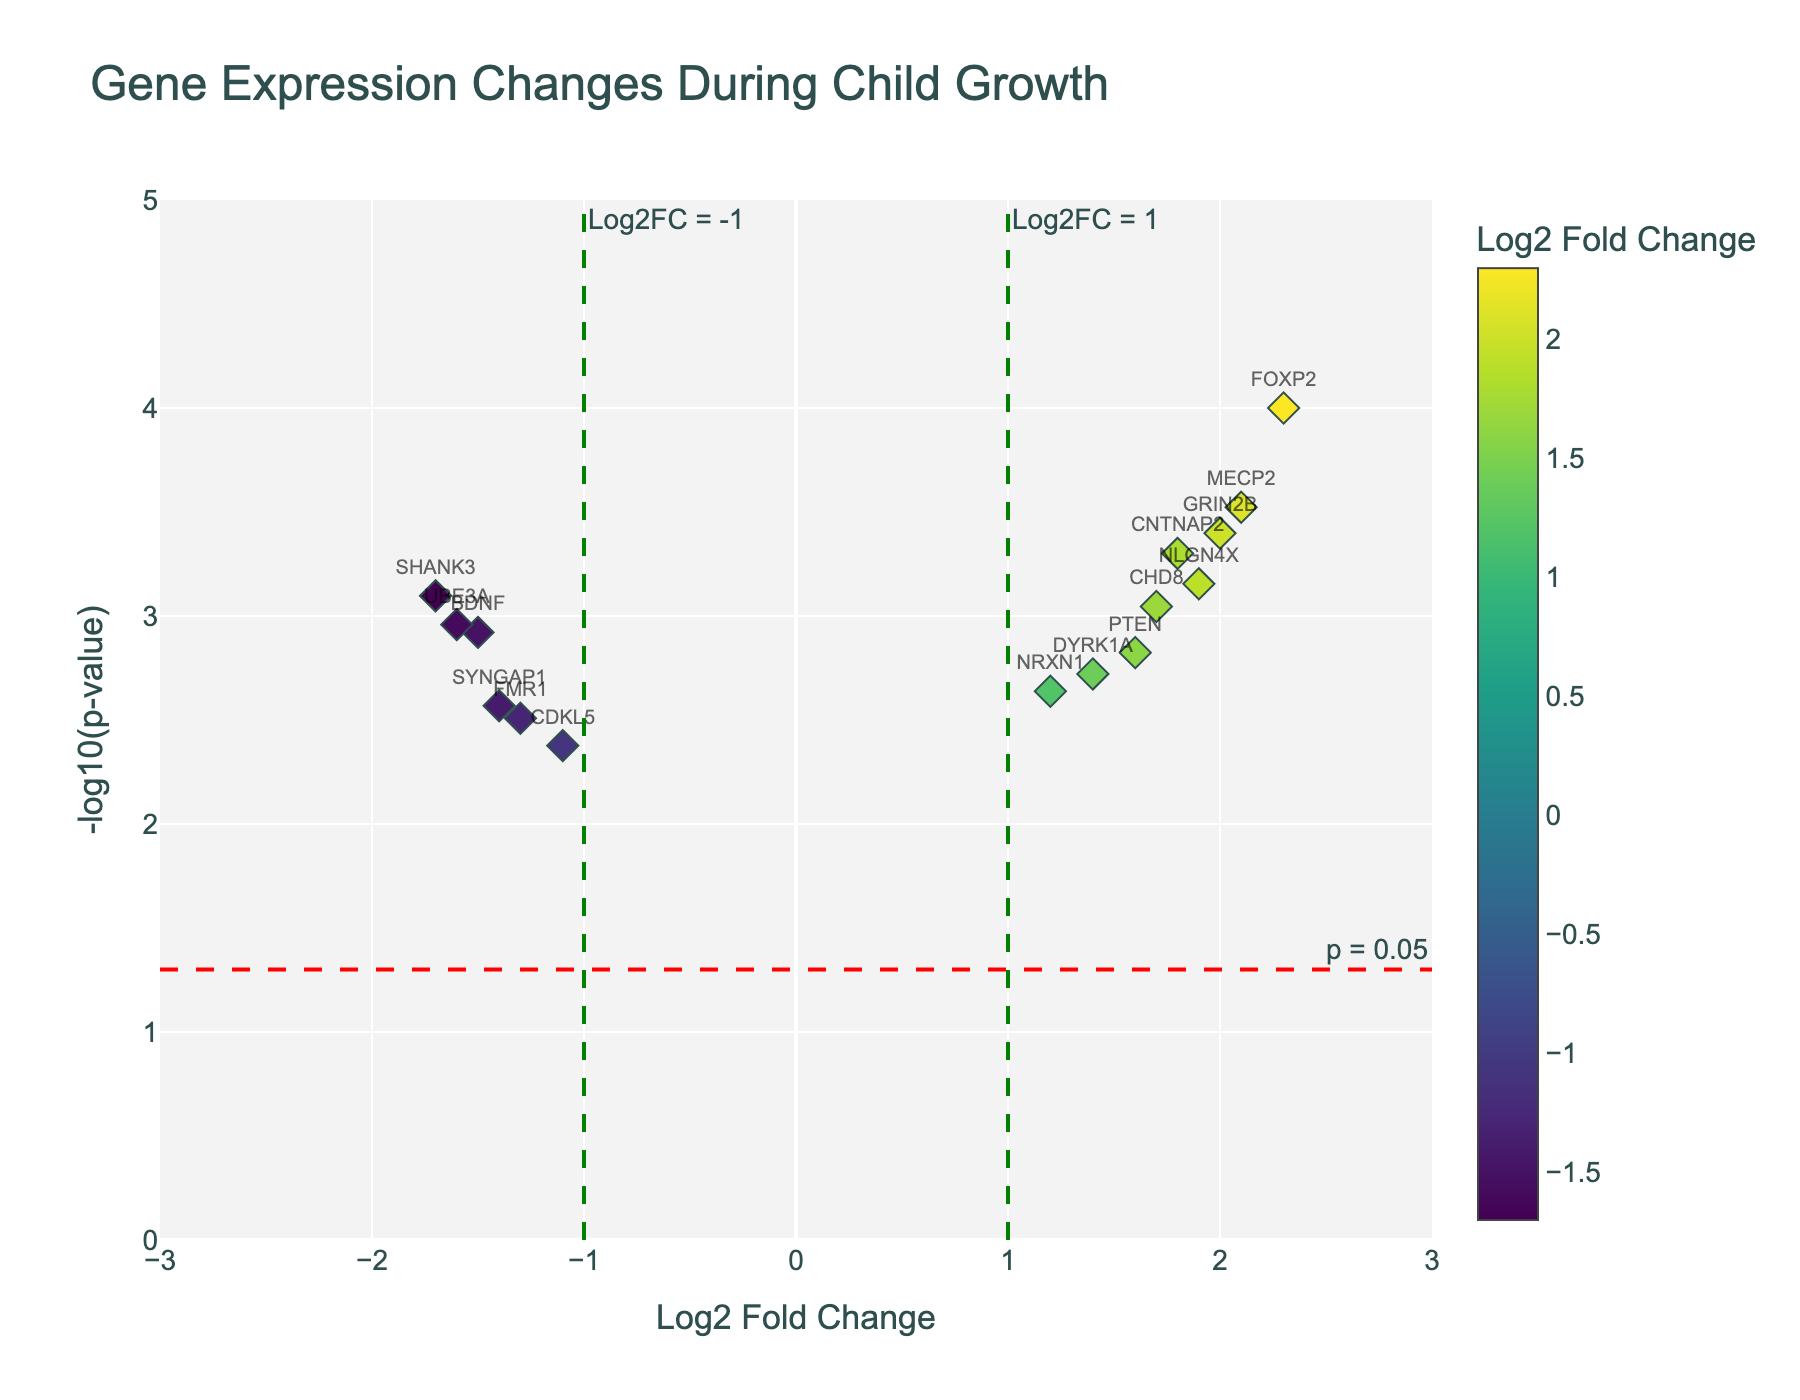What's the log2 fold change of the gene with the lowest p-value? To find the log2 fold change of the gene with the lowest p-value, locate the gene with the smallest p-value on the y-axis. Here, FOXP2 has the lowest p-value (highest -log10(p-value)). The log2 fold change for FOXP2 is 2.3.
Answer: 2.3 Which gene has the biggest decrease in expression (negative log2 fold change)? The gene with the biggest decrease in expression will have the most negative log2 fold change. By observing the x-axis for negative values, SHANK3 has the largest negative log2 fold change (-1.7).
Answer: SHANK3 How many genes have a significant change with a p-value less than 0.05? Count the data points above the horizontal line at -log10(0.05) which represents significant p-values. There are 15 points above this threshold.
Answer: 15 Which gene has the highest positive log2 fold change? Locate the point with the highest positive value on the x-axis. FOXP2, with a log2 fold change of 2.3, is the highest.
Answer: FOXP2 How many genes have both a log2 fold change greater than 1 and a p-value less than 0.05? Count the points that lie to the right of the vertical line at log2 fold change of 1 and above the horizontal line at -log10(0.05). There are 7 such genes (FOXP2, CNTNAP2, MECP2, NLGN4X, GRIN2B, CHD8, DYRK1A).
Answer: 7 What is the p-value of the gene with the log2 fold change of -1.6? Find the gene with a log2 fold change of -1.6 on the x-axis, which is UBE3A. Then, look at its y-value for -log10(p-value), convert back to p-value as 10^y. Here, it is -log10(0.0011) = 3.
Answer: 0.0011 Which genes have a log2 fold change between 1 and 2 and a p-value less than 0.001? Look for genes located between 1 and 2 on the x-axis and above -log10(0.001) (i.e., 3) on the y-axis. CNTNAP2, MECP2, and GRIN2B meet these criteria.
Answer: CNTNAP2, MECP2, GRIN2B Which gene shows a fold change closest to zero but is significant (p-value < 0.05)? Look for the point closest to the x-axis at x=0 that is also above the horizontal threshold line at -log10(0.05). NRXN1 has a Log2FoldChange of 1.2 and is significant.
Answer: NRXN1 